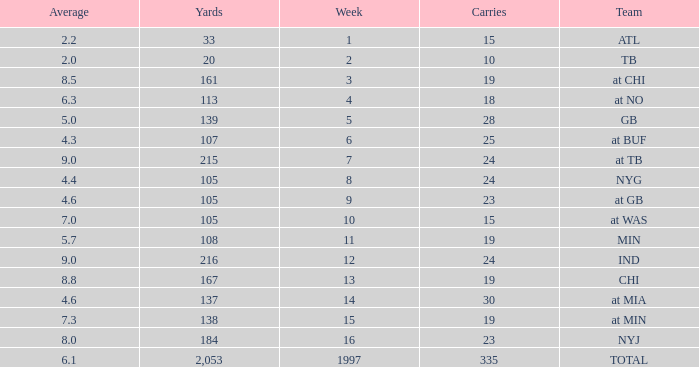Which Average has Yards larger than 167, and a Team of at tb, and a Week larger than 7? None. 